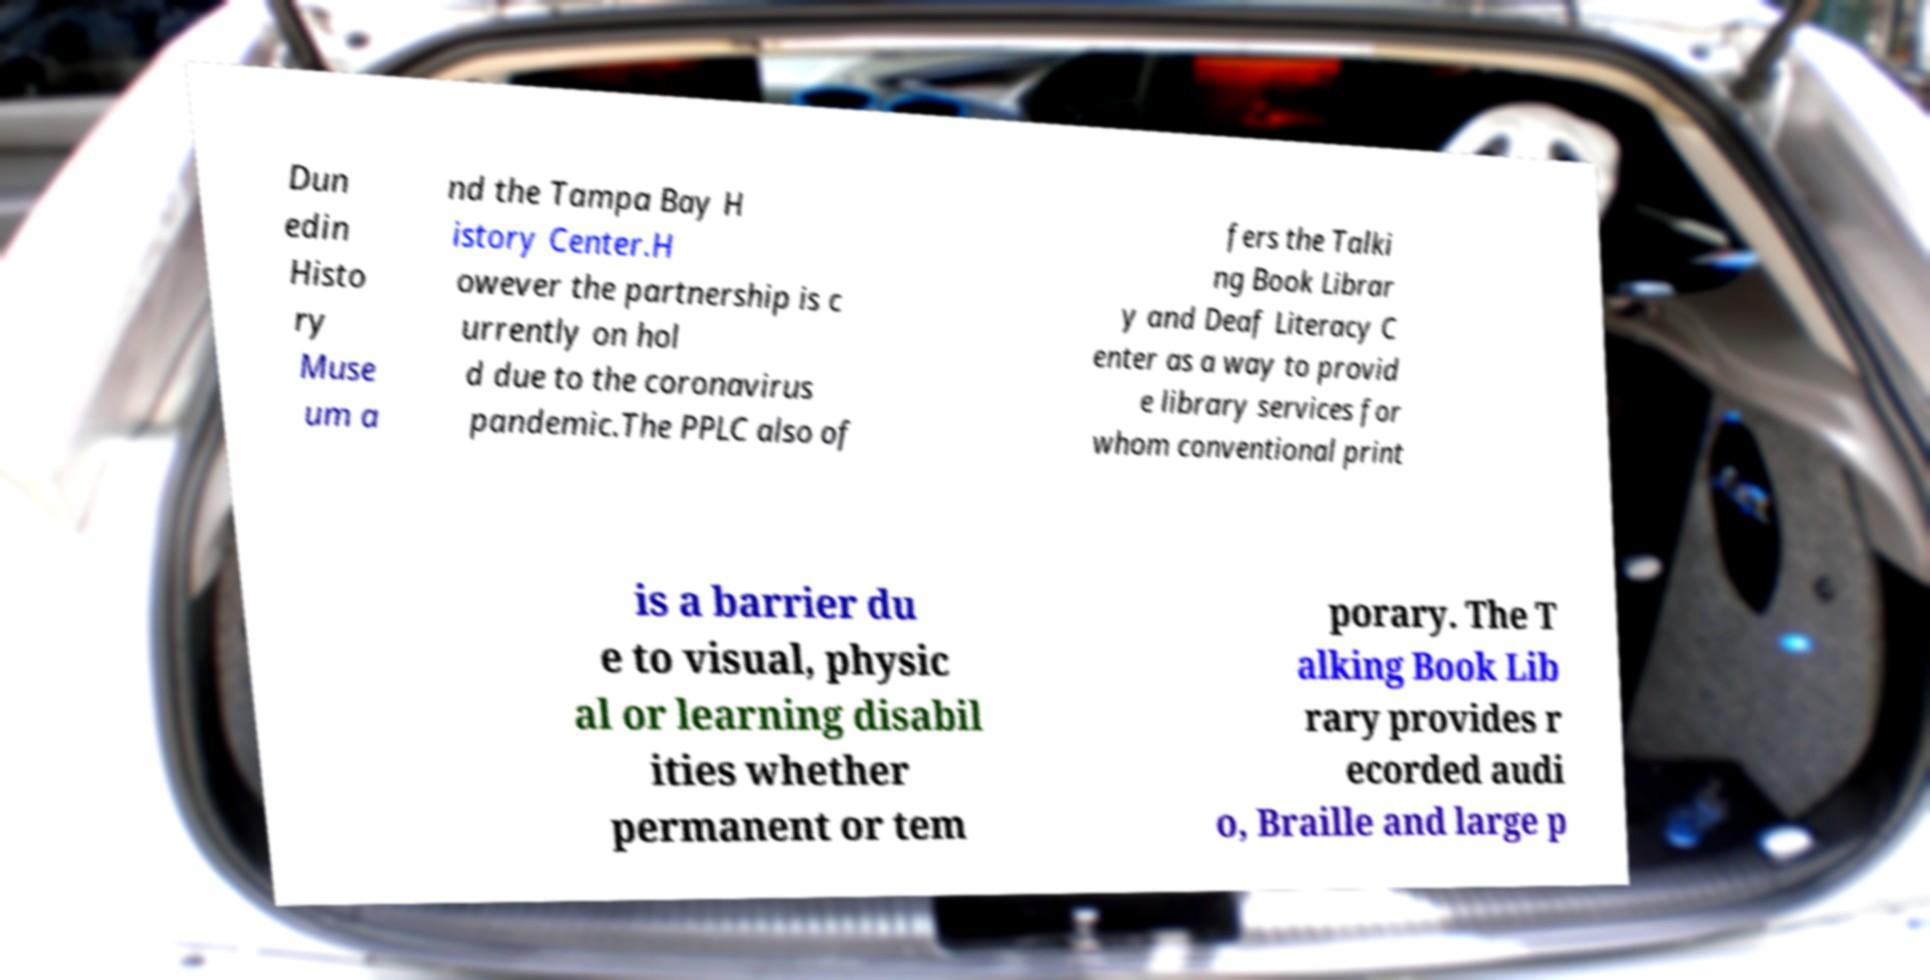I need the written content from this picture converted into text. Can you do that? Dun edin Histo ry Muse um a nd the Tampa Bay H istory Center.H owever the partnership is c urrently on hol d due to the coronavirus pandemic.The PPLC also of fers the Talki ng Book Librar y and Deaf Literacy C enter as a way to provid e library services for whom conventional print is a barrier du e to visual, physic al or learning disabil ities whether permanent or tem porary. The T alking Book Lib rary provides r ecorded audi o, Braille and large p 